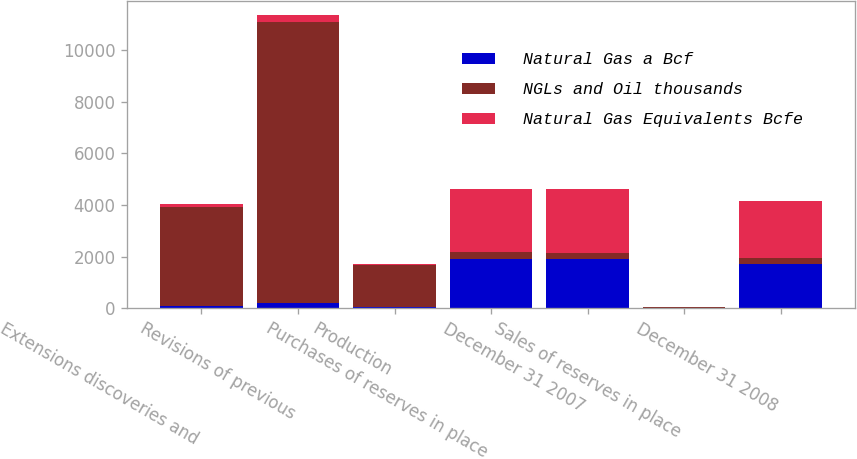<chart> <loc_0><loc_0><loc_500><loc_500><stacked_bar_chart><ecel><fcel>Extensions discoveries and<fcel>Revisions of previous<fcel>Production<fcel>Purchases of reserves in place<fcel>December 31 2007<fcel>Sales of reserves in place<fcel>December 31 2008<nl><fcel>Natural Gas a Bcf<fcel>62<fcel>185<fcel>34<fcel>1919<fcel>1896<fcel>1<fcel>1694<nl><fcel>NGLs and Oil thousands<fcel>3877<fcel>10925<fcel>1627<fcel>251<fcel>251<fcel>54<fcel>251<nl><fcel>Natural Gas Equivalents Bcfe<fcel>85<fcel>251<fcel>43<fcel>2470<fcel>2474<fcel>1<fcel>2203<nl></chart> 